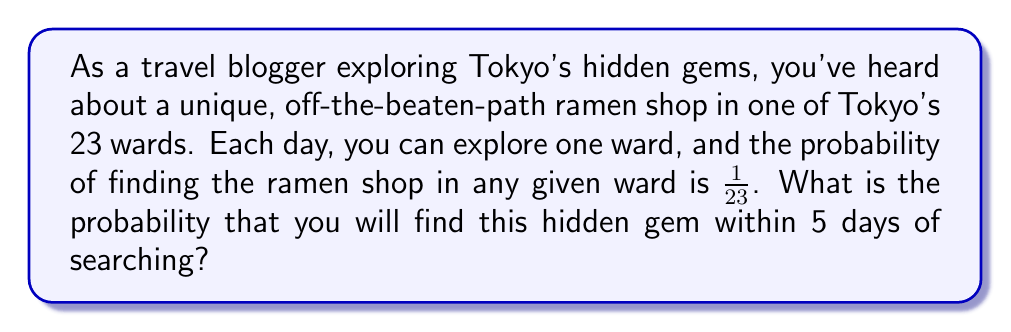Can you solve this math problem? To solve this problem, we need to use the concept of probability of an event not occurring and then subtract it from 1 to find the probability of the event occurring.

Let's approach this step-by-step:

1) First, let's calculate the probability of not finding the ramen shop in a single day:
   $P(\text{not finding in one day}) = 1 - \frac{1}{23} = \frac{22}{23}$

2) Now, for not finding the shop in 5 days, this event needs to occur 5 times in a row. We can calculate this using the multiplication rule of independent events:
   $P(\text{not finding in 5 days}) = (\frac{22}{23})^5$

3) Therefore, the probability of finding the shop within 5 days is the opposite of not finding it in 5 days:
   $P(\text{finding within 5 days}) = 1 - P(\text{not finding in 5 days})$

4) Let's calculate this:
   $P(\text{finding within 5 days}) = 1 - (\frac{22}{23})^5$

5) Using a calculator (or computer) to evaluate this expression:
   $1 - (\frac{22}{23})^5 \approx 0.1979$

6) Converting to a percentage:
   $0.1979 \times 100\% \approx 19.79\%$
Answer: The probability of finding the hidden gem ramen shop within 5 days is approximately 19.79% or 0.1979. 